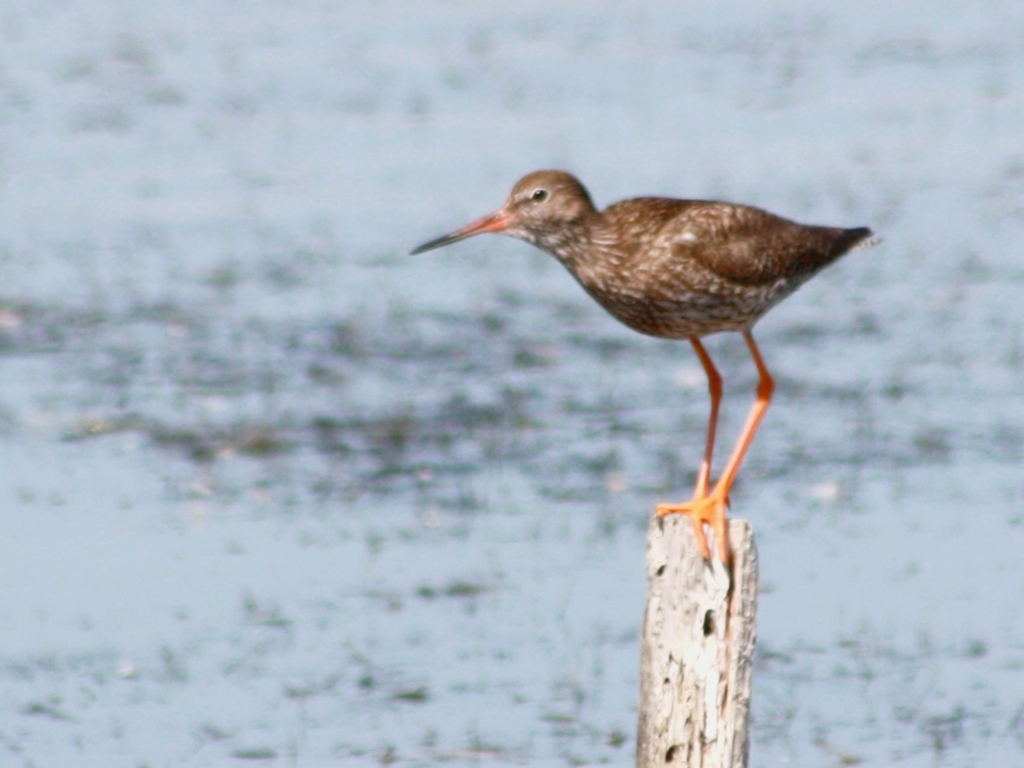What is the quality of the image? The image quality is medium or average due to several factors. While the subject, a bird, is in focus, with details like its feather texture and leg color being relatively sharp, the background appears overexposed, affecting overall clarity. Additionally, the motion blur on the bird's beak suggests that the shutter speed wasn't fast enough to freeze the action completely, contributing to a less crisp image. 